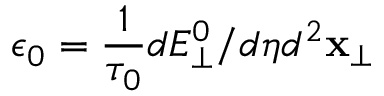<formula> <loc_0><loc_0><loc_500><loc_500>\epsilon _ { 0 } = \frac { 1 } { \tau _ { 0 } } d E _ { \perp } ^ { 0 } / d \eta d ^ { 2 } x _ { \perp }</formula> 